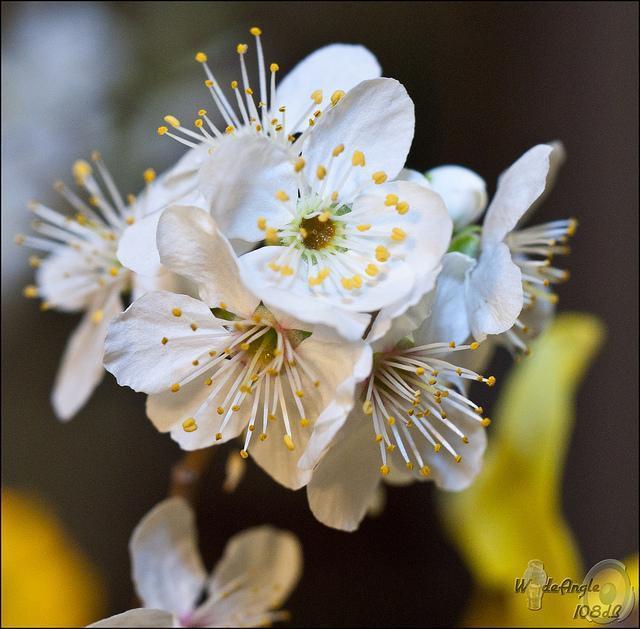How many yellow dots are on the flower?
Give a very brief answer. 0. 